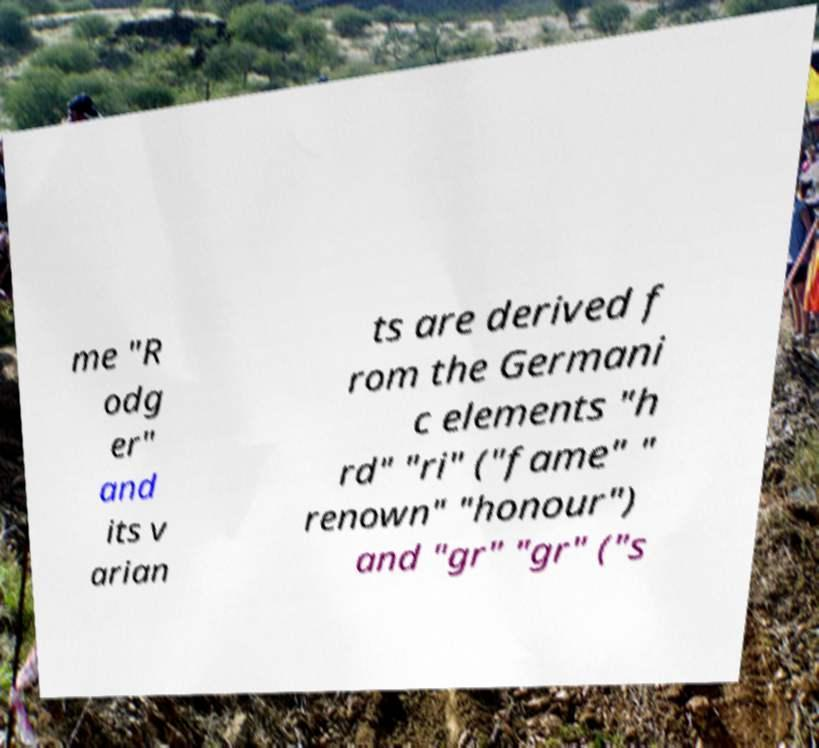Please read and relay the text visible in this image. What does it say? me "R odg er" and its v arian ts are derived f rom the Germani c elements "h rd" "ri" ("fame" " renown" "honour") and "gr" "gr" ("s 